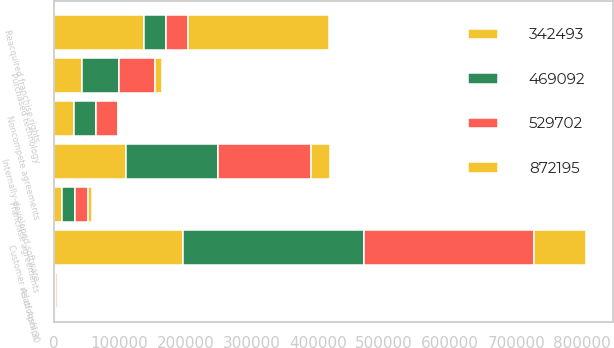Convert chart to OTSL. <chart><loc_0><loc_0><loc_500><loc_500><stacked_bar_chart><ecel><fcel>As of April 30<fcel>Reacquired franchise rights<fcel>Customer relationships<fcel>Internally-developed software<fcel>Noncompete agreements<fcel>Franchise agreements<fcel>Purchased technology<nl><fcel>469092<fcel>2019<fcel>33137.5<fcel>274838<fcel>139239<fcel>33376<fcel>19201<fcel>54700<nl><fcel>342493<fcel>2019<fcel>136345<fcel>195174<fcel>109885<fcel>31446<fcel>13334<fcel>43518<nl><fcel>872195<fcel>2019<fcel>214065<fcel>79664<fcel>29354<fcel>1930<fcel>5867<fcel>11182<nl><fcel>529702<fcel>2018<fcel>33137.5<fcel>256137<fcel>140255<fcel>32899<fcel>19201<fcel>54700<nl></chart> 